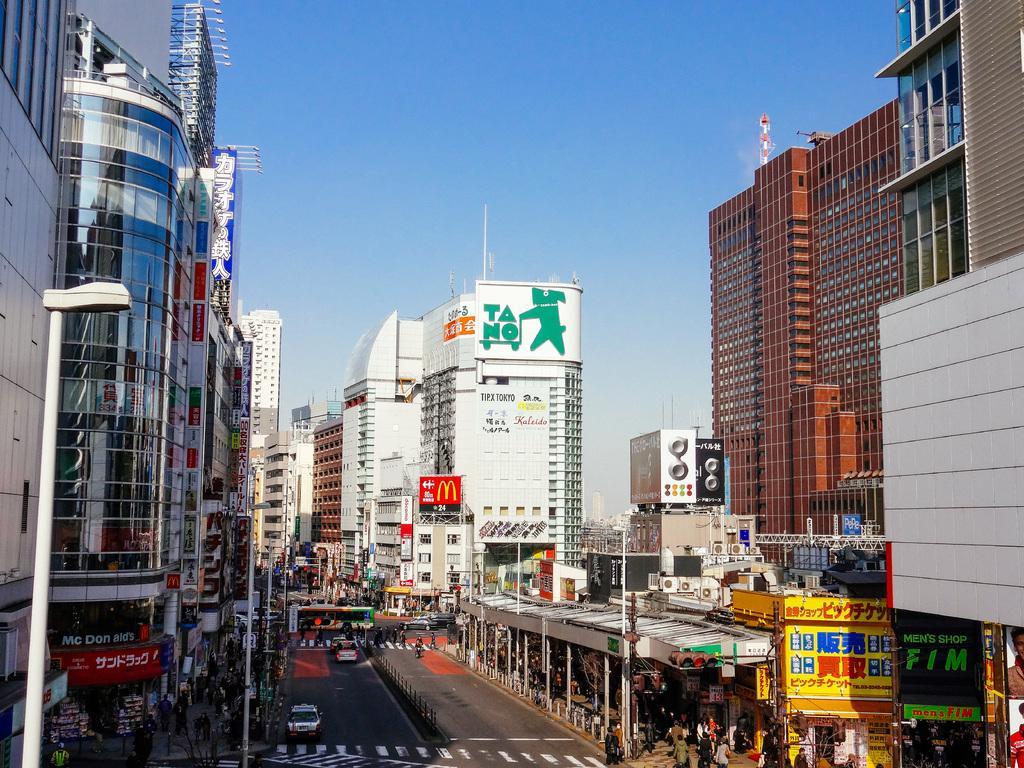Can you describe this image briefly? This image is clicked outside. In the front, we can see many buildings. At the top, there is sky. At the bottom, there is a road. There are many persons and vehicles in this image. 